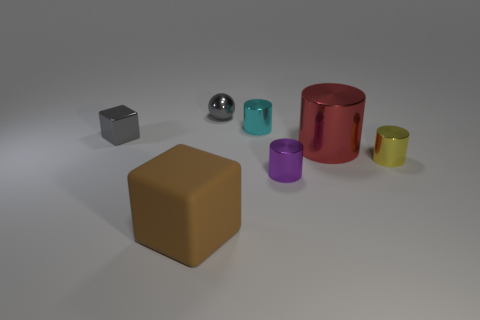Subtract all big cylinders. How many cylinders are left? 3 Add 1 brown metallic spheres. How many objects exist? 8 Subtract 2 cylinders. How many cylinders are left? 2 Subtract all cyan cylinders. How many cylinders are left? 3 Subtract all blue cylinders. Subtract all yellow spheres. How many cylinders are left? 4 Subtract all cubes. How many objects are left? 5 Add 4 yellow blocks. How many yellow blocks exist? 4 Subtract 0 red blocks. How many objects are left? 7 Subtract all tiny yellow things. Subtract all gray spheres. How many objects are left? 5 Add 6 tiny yellow cylinders. How many tiny yellow cylinders are left? 7 